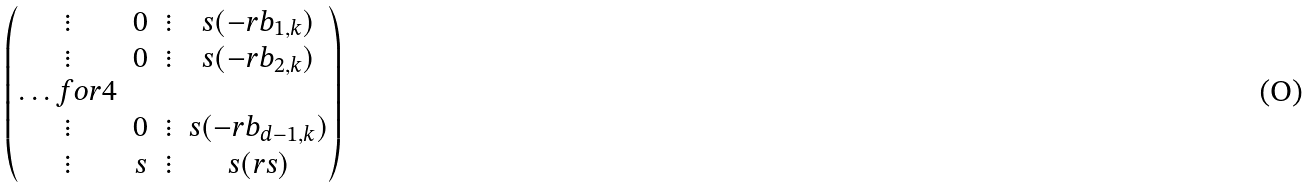Convert formula to latex. <formula><loc_0><loc_0><loc_500><loc_500>\begin{pmatrix} \vdots & 0 & \vdots & s ( - r b _ { 1 , k } ) \\ \vdots & 0 & \vdots & s ( - r b _ { 2 , k } ) \\ \hdots f o r { 4 } \\ \vdots & 0 & \vdots & s ( - r b _ { d - 1 , k } ) \\ \vdots & s & \vdots & s ( r s ) \\ \end{pmatrix}</formula> 